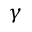Convert formula to latex. <formula><loc_0><loc_0><loc_500><loc_500>\gamma</formula> 